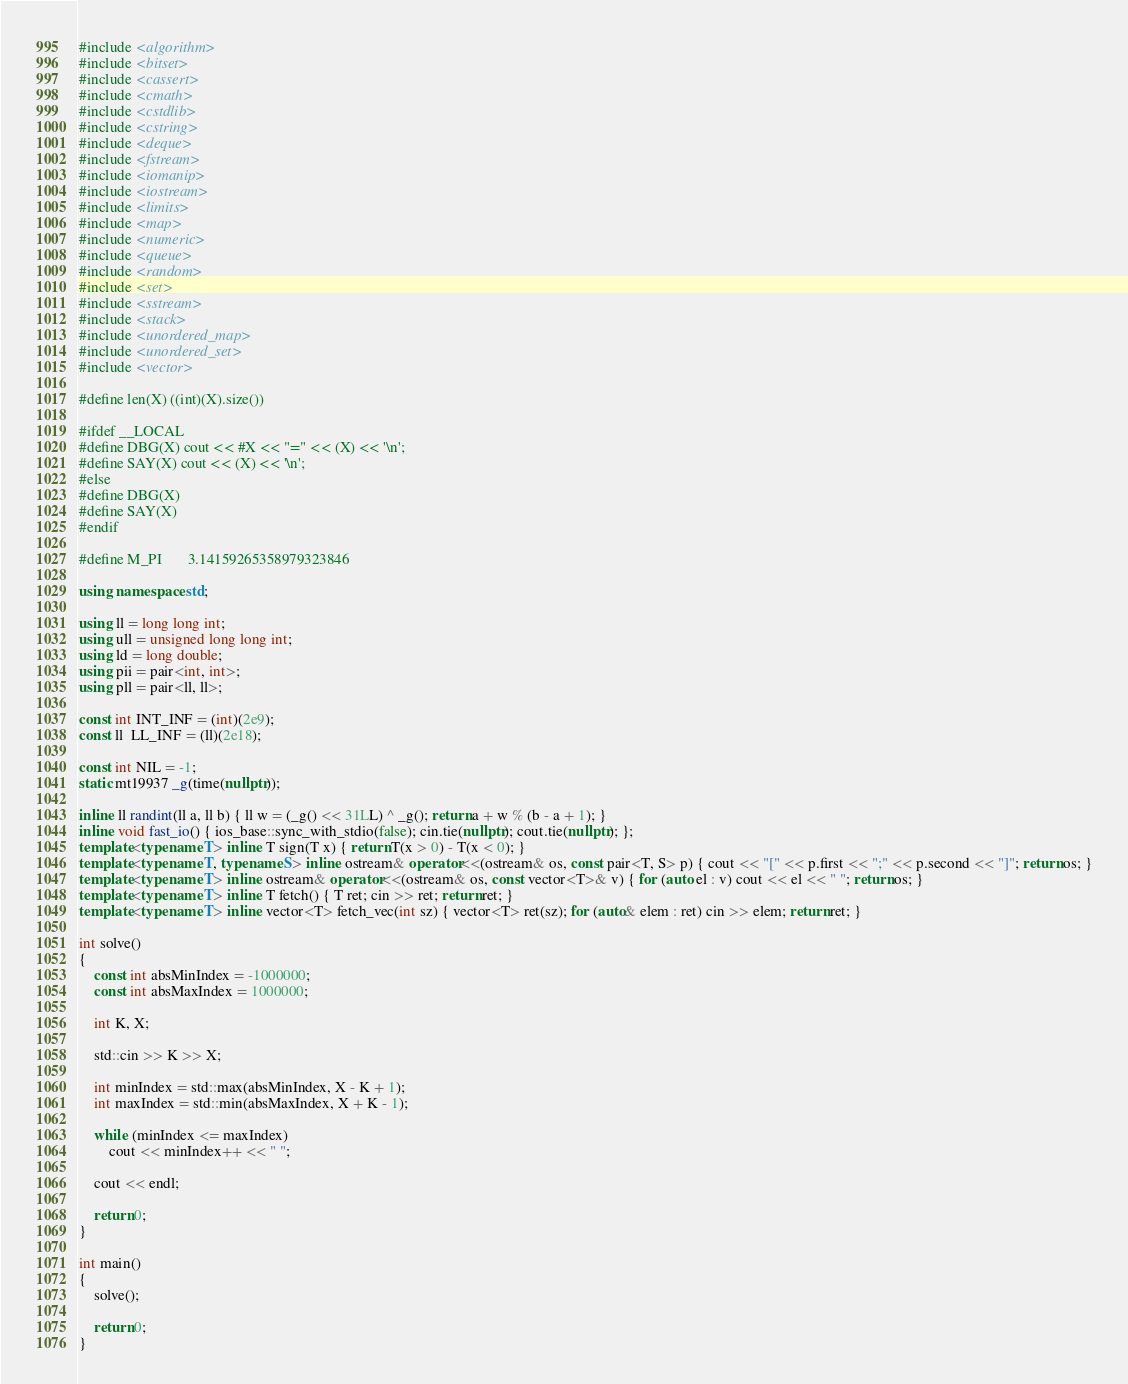Convert code to text. <code><loc_0><loc_0><loc_500><loc_500><_C++_>#include <algorithm>
#include <bitset>
#include <cassert>
#include <cmath>
#include <cstdlib>
#include <cstring>
#include <deque>
#include <fstream>
#include <iomanip>
#include <iostream>
#include <limits>
#include <map>
#include <numeric>
#include <queue>
#include <random>
#include <set>
#include <sstream>
#include <stack>
#include <unordered_map>
#include <unordered_set>
#include <vector>

#define len(X) ((int)(X).size())

#ifdef __LOCAL
#define DBG(X) cout << #X << "=" << (X) << '\n';
#define SAY(X) cout << (X) << '\n';
#else
#define DBG(X)
#define SAY(X)
#endif

#define M_PI       3.14159265358979323846

using namespace std;

using ll = long long int;
using ull = unsigned long long int;
using ld = long double;
using pii = pair<int, int>;
using pll = pair<ll, ll>;

const int INT_INF = (int)(2e9);
const ll  LL_INF = (ll)(2e18);

const int NIL = -1;
static mt19937 _g(time(nullptr));

inline ll randint(ll a, ll b) { ll w = (_g() << 31LL) ^ _g(); return a + w % (b - a + 1); }
inline void fast_io() { ios_base::sync_with_stdio(false); cin.tie(nullptr); cout.tie(nullptr); };
template<typename T> inline T sign(T x) { return T(x > 0) - T(x < 0); }
template<typename T, typename S> inline ostream& operator<<(ostream& os, const pair<T, S> p) { cout << "[" << p.first << ";" << p.second << "]"; return os; }
template<typename T> inline ostream& operator<<(ostream& os, const vector<T>& v) { for (auto el : v) cout << el << " "; return os; }
template<typename T> inline T fetch() { T ret; cin >> ret; return ret; }
template<typename T> inline vector<T> fetch_vec(int sz) { vector<T> ret(sz); for (auto& elem : ret) cin >> elem; return ret; }

int solve()
{
    const int absMinIndex = -1000000;
    const int absMaxIndex = 1000000;

    int K, X;

    std::cin >> K >> X;

    int minIndex = std::max(absMinIndex, X - K + 1);
    int maxIndex = std::min(absMaxIndex, X + K - 1);

    while (minIndex <= maxIndex)
        cout << minIndex++ << " ";

    cout << endl;

    return 0;
}

int main()
{
    solve();

    return 0;
}</code> 